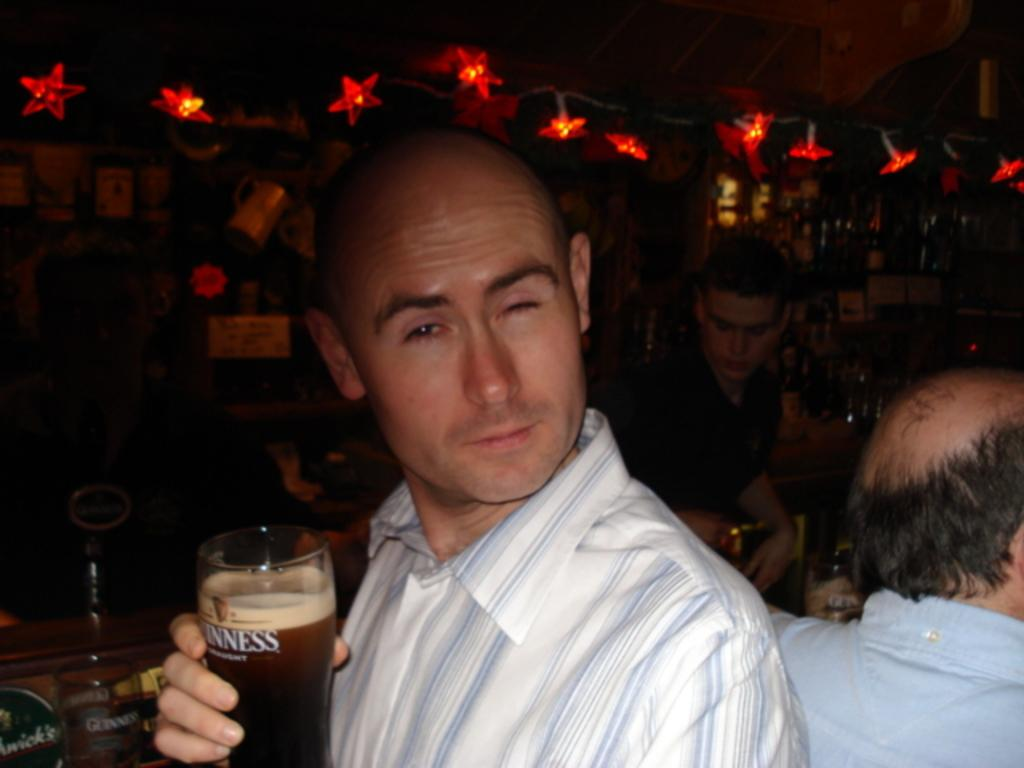What is the person in the image holding? The person in the image is holding a glass. Can you describe the people surrounding the person holding the glass? There is a group of persons standing beside the person holding the glass. What can be seen in the background of the image? There are lights and a wall in the background of the image. What else is present in the background of the image? There are bottles on a table in the background of the image. Can you tell me how many corks are floating in the seashore in the image? There is no seashore or corks present in the image. Are there any giants visible in the image? There are no giants present in the image. 